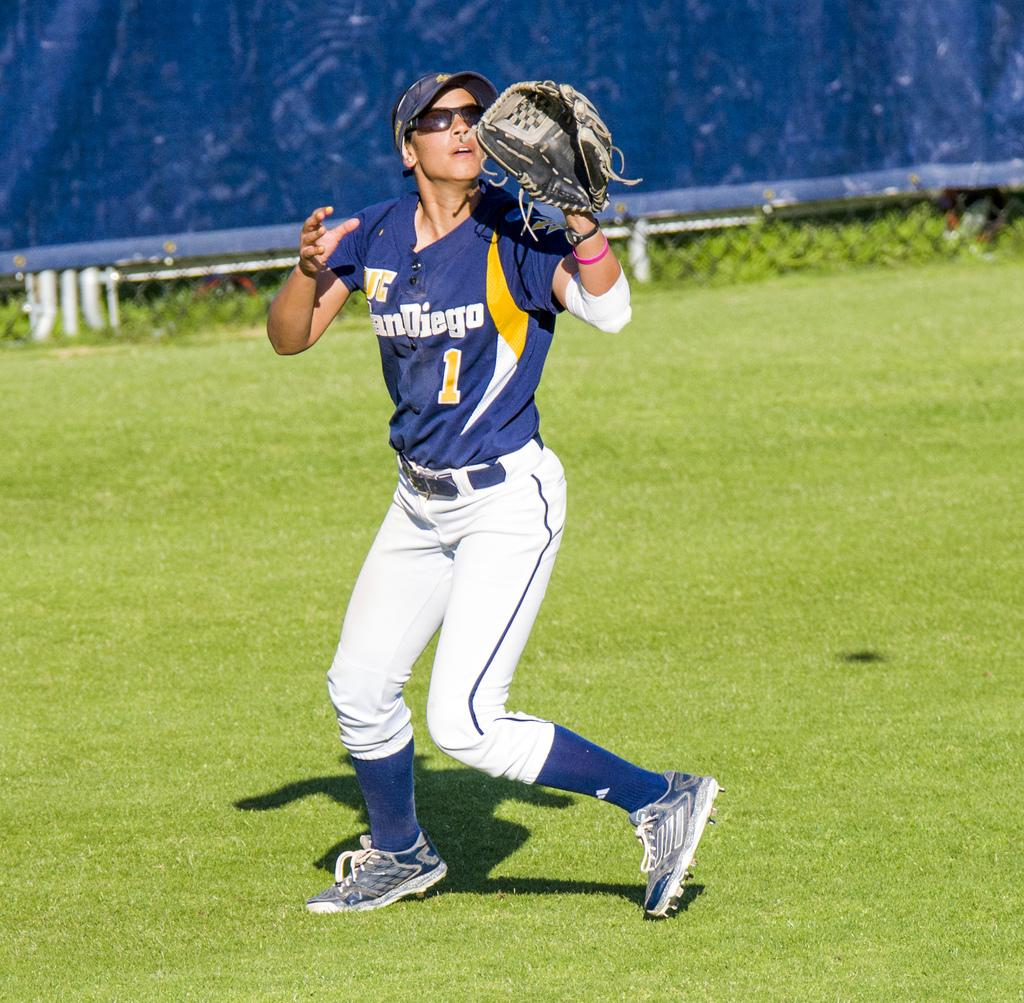What is present in the image? There is a person in the image. Can you describe the person's attire? The person is wearing clothes, socks, shoes, a cap, and goggles. They are also holding gloves in one hand. What can be seen in the background of the image? The background of the image is blue, and there is grass visible. What type of steel is being used to make the kettle in the image? There is no kettle present in the image, so it is not possible to determine the type of steel being used. 